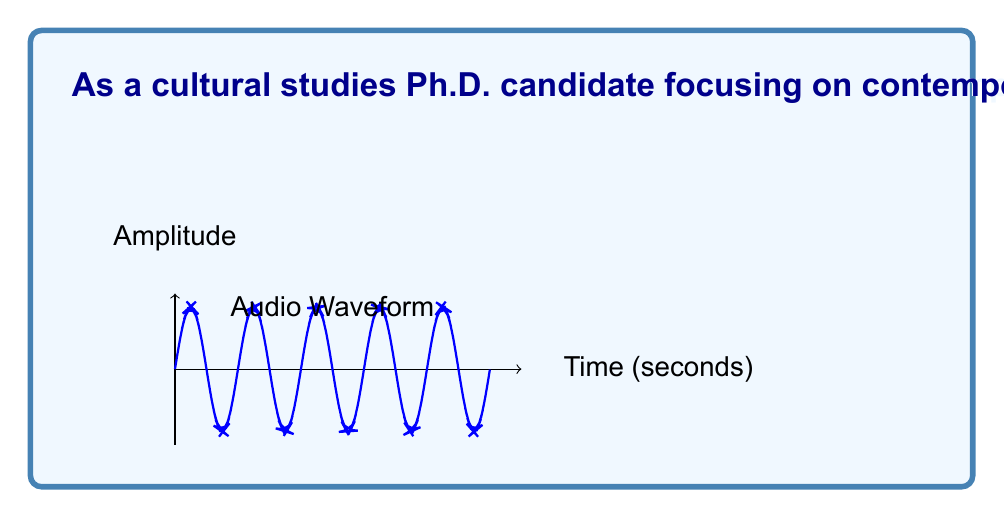Can you answer this question? Let's break this down step-by-step:

1) First, we need to calculate the number of samples:
   - Duration: 5 minutes = 300 seconds
   - Sampling rate: 48 kHz = 48,000 samples per second
   - Stereo audio: 2 channels

   Total samples = $300 \text{ s} \times 48,000 \text{ samples/s} \times 2 \text{ channels}$
                 = $28,800,000$ samples

2) Each sample is represented by a 32-bit (4-byte) floating-point number:
   
   Space per sample = 4 bytes

3) Total space required:
   
   $\text{Total space} = 28,800,000 \text{ samples} \times 4 \text{ bytes/sample}$
                       = $115,200,000 \text{ bytes}$
                       = $115,200 \text{ KB}$
                       = $112.5 \text{ MB}$

4) In terms of space complexity, we express this as a function of the input size. Here, the input size can be considered as the duration of the audio (n seconds).

5) The space required grows linearly with the duration of the audio. For every second of audio, we need:
   
   $48,000 \text{ samples/s} \times 2 \text{ channels} \times 4 \text{ bytes/sample} = 384,000 \text{ bytes/s}$

Therefore, the space complexity is $O(n)$, where n is the duration of the audio in seconds.
Answer: $O(n)$ 